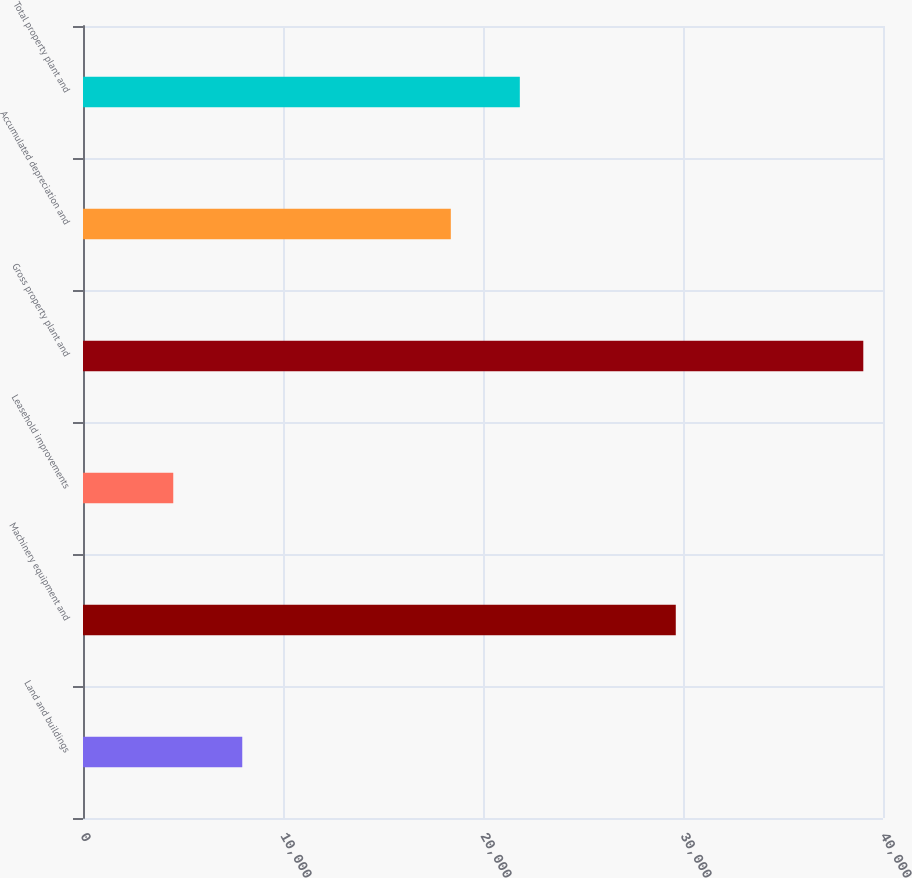<chart> <loc_0><loc_0><loc_500><loc_500><bar_chart><fcel>Land and buildings<fcel>Machinery equipment and<fcel>Leasehold improvements<fcel>Gross property plant and<fcel>Accumulated depreciation and<fcel>Total property plant and<nl><fcel>7963.2<fcel>29639<fcel>4513<fcel>39015<fcel>18391<fcel>21841.2<nl></chart> 